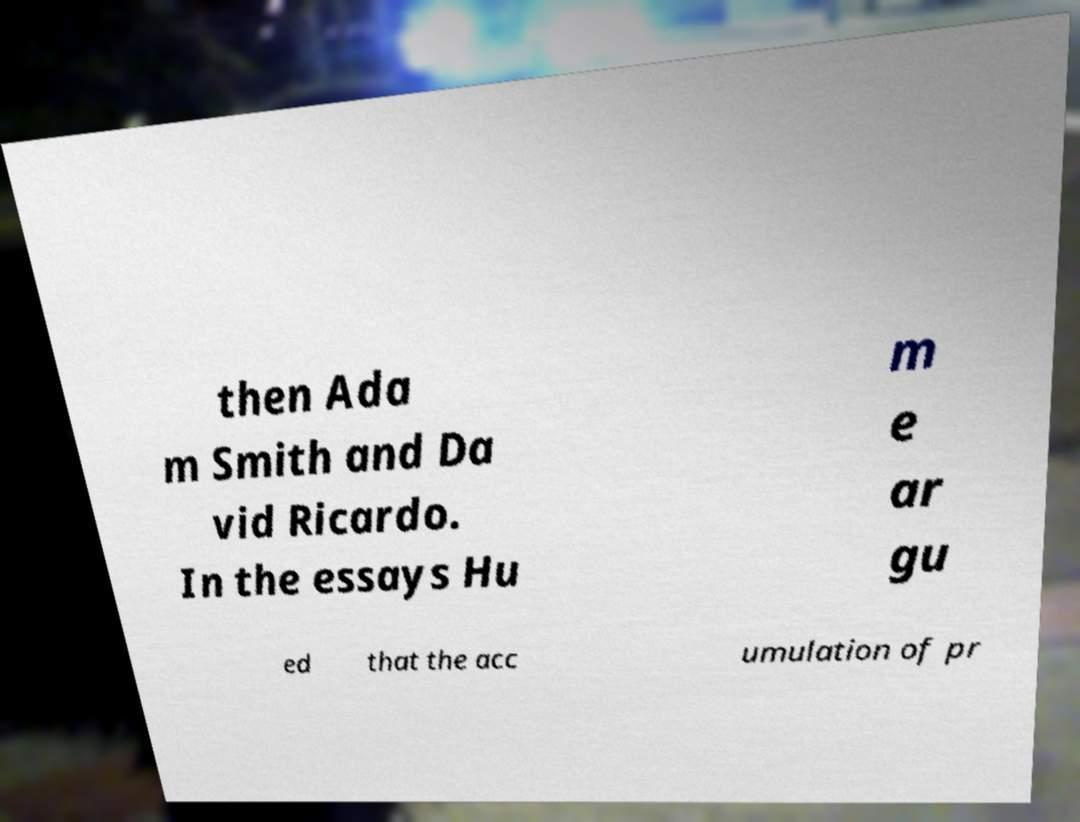Please read and relay the text visible in this image. What does it say? then Ada m Smith and Da vid Ricardo. In the essays Hu m e ar gu ed that the acc umulation of pr 